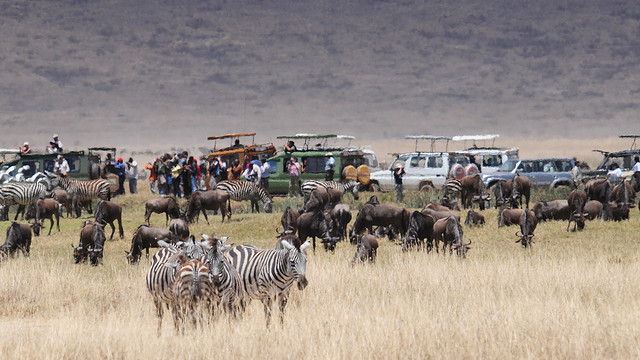Can you describe the environment where these animals are found? Certainly! The environment in the image appears to be a savanna, characterized by wide open grasslands with a sparse distribution of trees or bushes. This type of ecosystem is typical in regions of Africa, supporting a large biodiversity, including the herbivores we see here, which are often found in herds and attract safari-goers for wildlife viewing. 